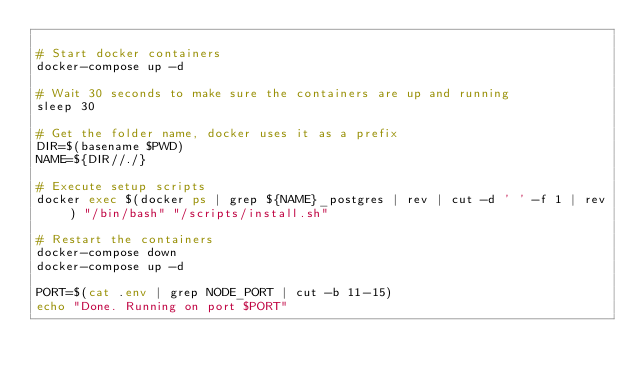Convert code to text. <code><loc_0><loc_0><loc_500><loc_500><_Bash_>
# Start docker containers
docker-compose up -d

# Wait 30 seconds to make sure the containers are up and running
sleep 30

# Get the folder name, docker uses it as a prefix
DIR=$(basename $PWD)
NAME=${DIR//./}

# Execute setup scripts
docker exec $(docker ps | grep ${NAME}_postgres | rev | cut -d ' ' -f 1 | rev) "/bin/bash" "/scripts/install.sh"

# Restart the containers
docker-compose down
docker-compose up -d

PORT=$(cat .env | grep NODE_PORT | cut -b 11-15)
echo "Done. Running on port $PORT"
</code> 